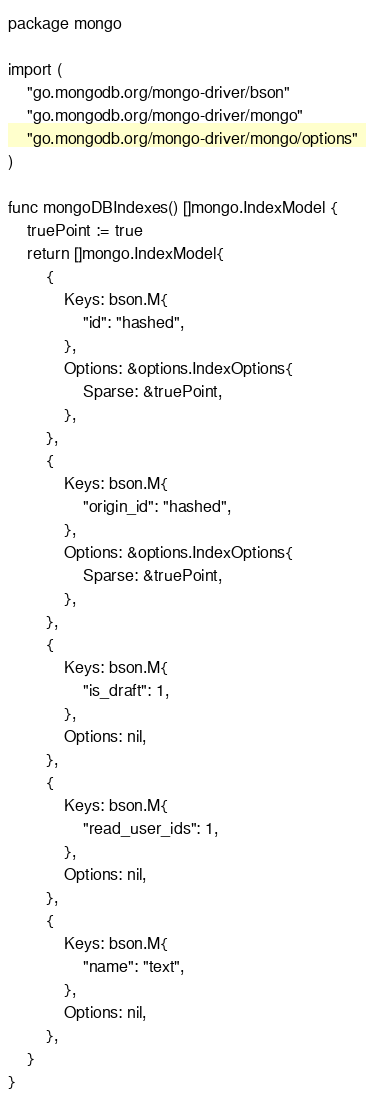Convert code to text. <code><loc_0><loc_0><loc_500><loc_500><_Go_>package mongo

import (
	"go.mongodb.org/mongo-driver/bson"
	"go.mongodb.org/mongo-driver/mongo"
	"go.mongodb.org/mongo-driver/mongo/options"
)

func mongoDBIndexes() []mongo.IndexModel {
	truePoint := true
	return []mongo.IndexModel{
		{
			Keys: bson.M{
				"id": "hashed",
			},
			Options: &options.IndexOptions{
				Sparse: &truePoint,
			},
		},
		{
			Keys: bson.M{
				"origin_id": "hashed",
			},
			Options: &options.IndexOptions{
				Sparse: &truePoint,
			},
		},
		{
			Keys: bson.M{
				"is_draft": 1,
			},
			Options: nil,
		},
		{
			Keys: bson.M{
				"read_user_ids": 1,
			},
			Options: nil,
		},
		{
			Keys: bson.M{
				"name": "text",
			},
			Options: nil,
		},
	}
}
</code> 